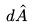Convert formula to latex. <formula><loc_0><loc_0><loc_500><loc_500>d \hat { A }</formula> 